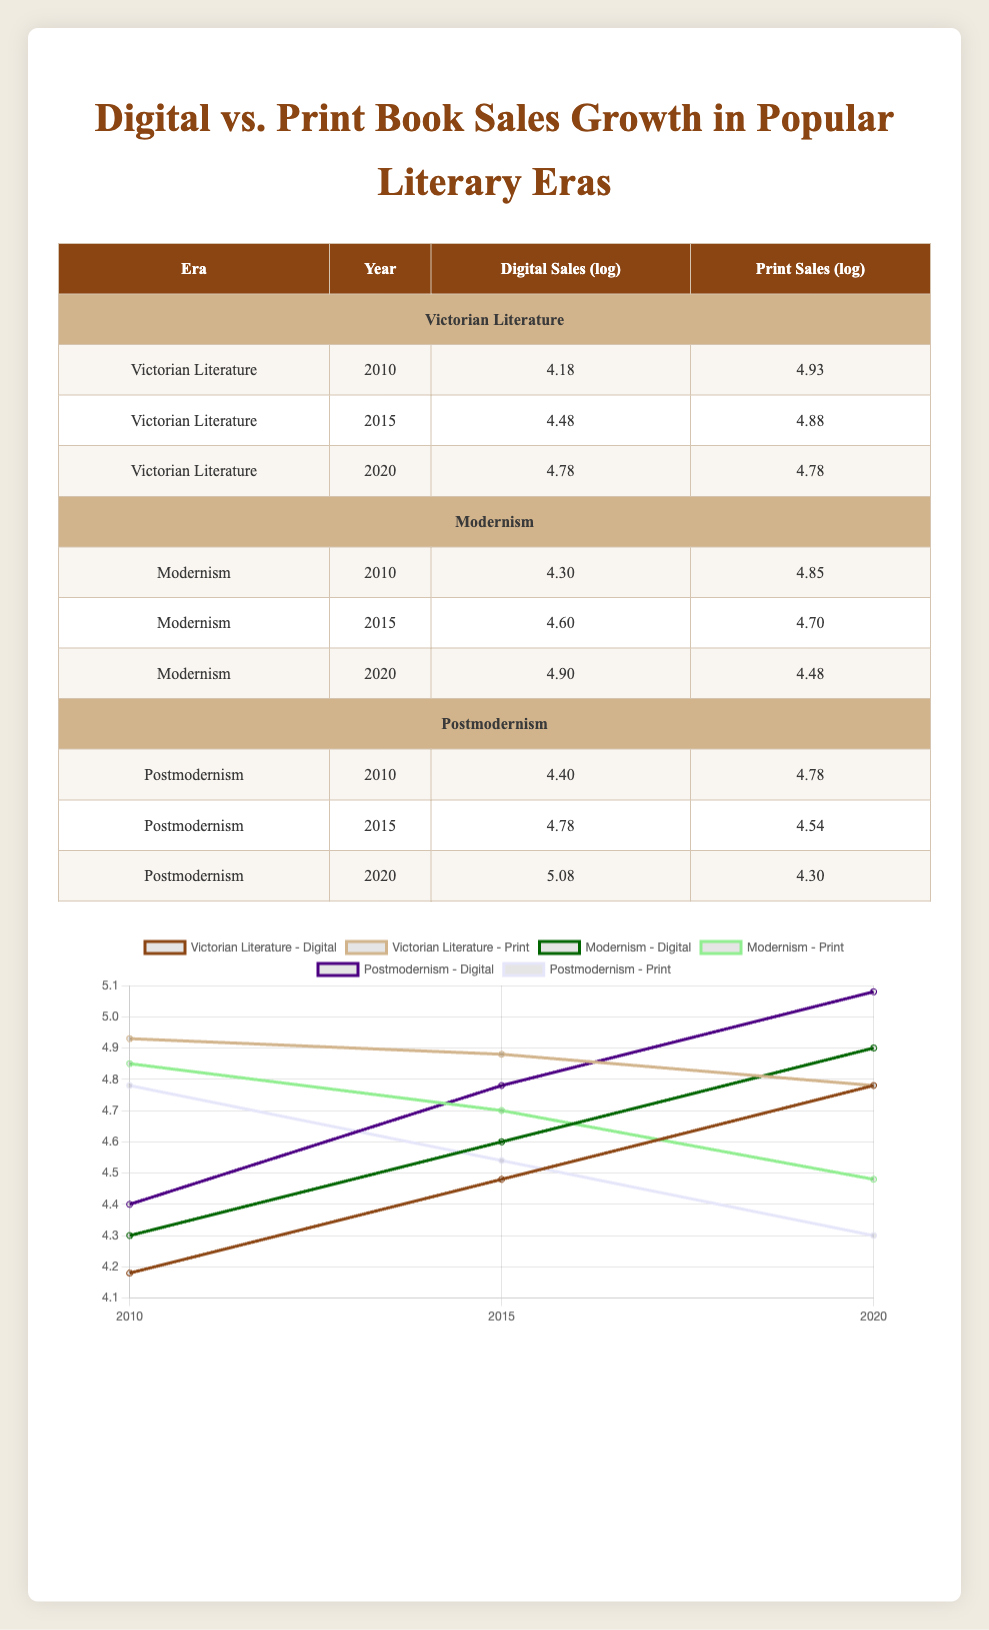What were the digital sales for Postmodernism in 2020? Referring to the table, the row for Postmodernism in 2020 shows the digital sales value as 120000.
Answer: 120000 What is the growth in digital sales for Victorian Literature from 2010 to 2020? For Victorian Literature, digital sales in 2010 were 15000 and in 2020, they were 60000. The growth is calculated as 60000 - 15000 = 45000.
Answer: 45000 Did print sales in Modernism increase from 2010 to 2015? The table shows that print sales for Modernism were 70000 in 2010 and decreased to 50000 in 2015. Therefore, print sales did not increase.
Answer: No What is the average logarithmic value of digital sales for Postmodernism across all years? To find the average, we sum the digital sales logarithmic values for Postmodernism: (4.40 + 4.78 + 5.08) = 14.26. We then divide by the number of years (3), giving us an average of 14.26/3 ≈ 4.75.
Answer: 4.75 Which era had the highest digital sales logged in 2020? Checking the table, Postmodernism had digital sales of 120000 in 2020, which is greater than both Victorian Literature (60000) and Modernism (80000) for that year.
Answer: Postmodernism What is the difference in logged print sales between Modernism in 2010 and Postmodernism in 2015? The print sales logged for Modernism in 2010 are 4.85 and for Postmodernism in 2015, it's 4.54. The difference is calculated as 4.85 - 4.54 = 0.31.
Answer: 0.31 Did the digital sales of Victorian Literature surpass its print sales in 2020? In 2020, Victorian Literature had digital sales of 60000 and print sales of also 60000. Since they are equal, the digital sales did not surpass print sales.
Answer: No What was the overall trend in digital sales for Modernism from 2010 to 2020? Looking at the digital sales for Modernism: 20000 in 2010, 40000 in 2015, and 80000 in 2020 shows an increasing trend, as the values consistently rise each year.
Answer: Increasing Which era experienced a decline in print sales between 2015 and 2020? Referring to the table, the print sales for Modernism declined from 50000 in 2015 to 30000 in 2020, demonstrating a downward trend.
Answer: Modernism 